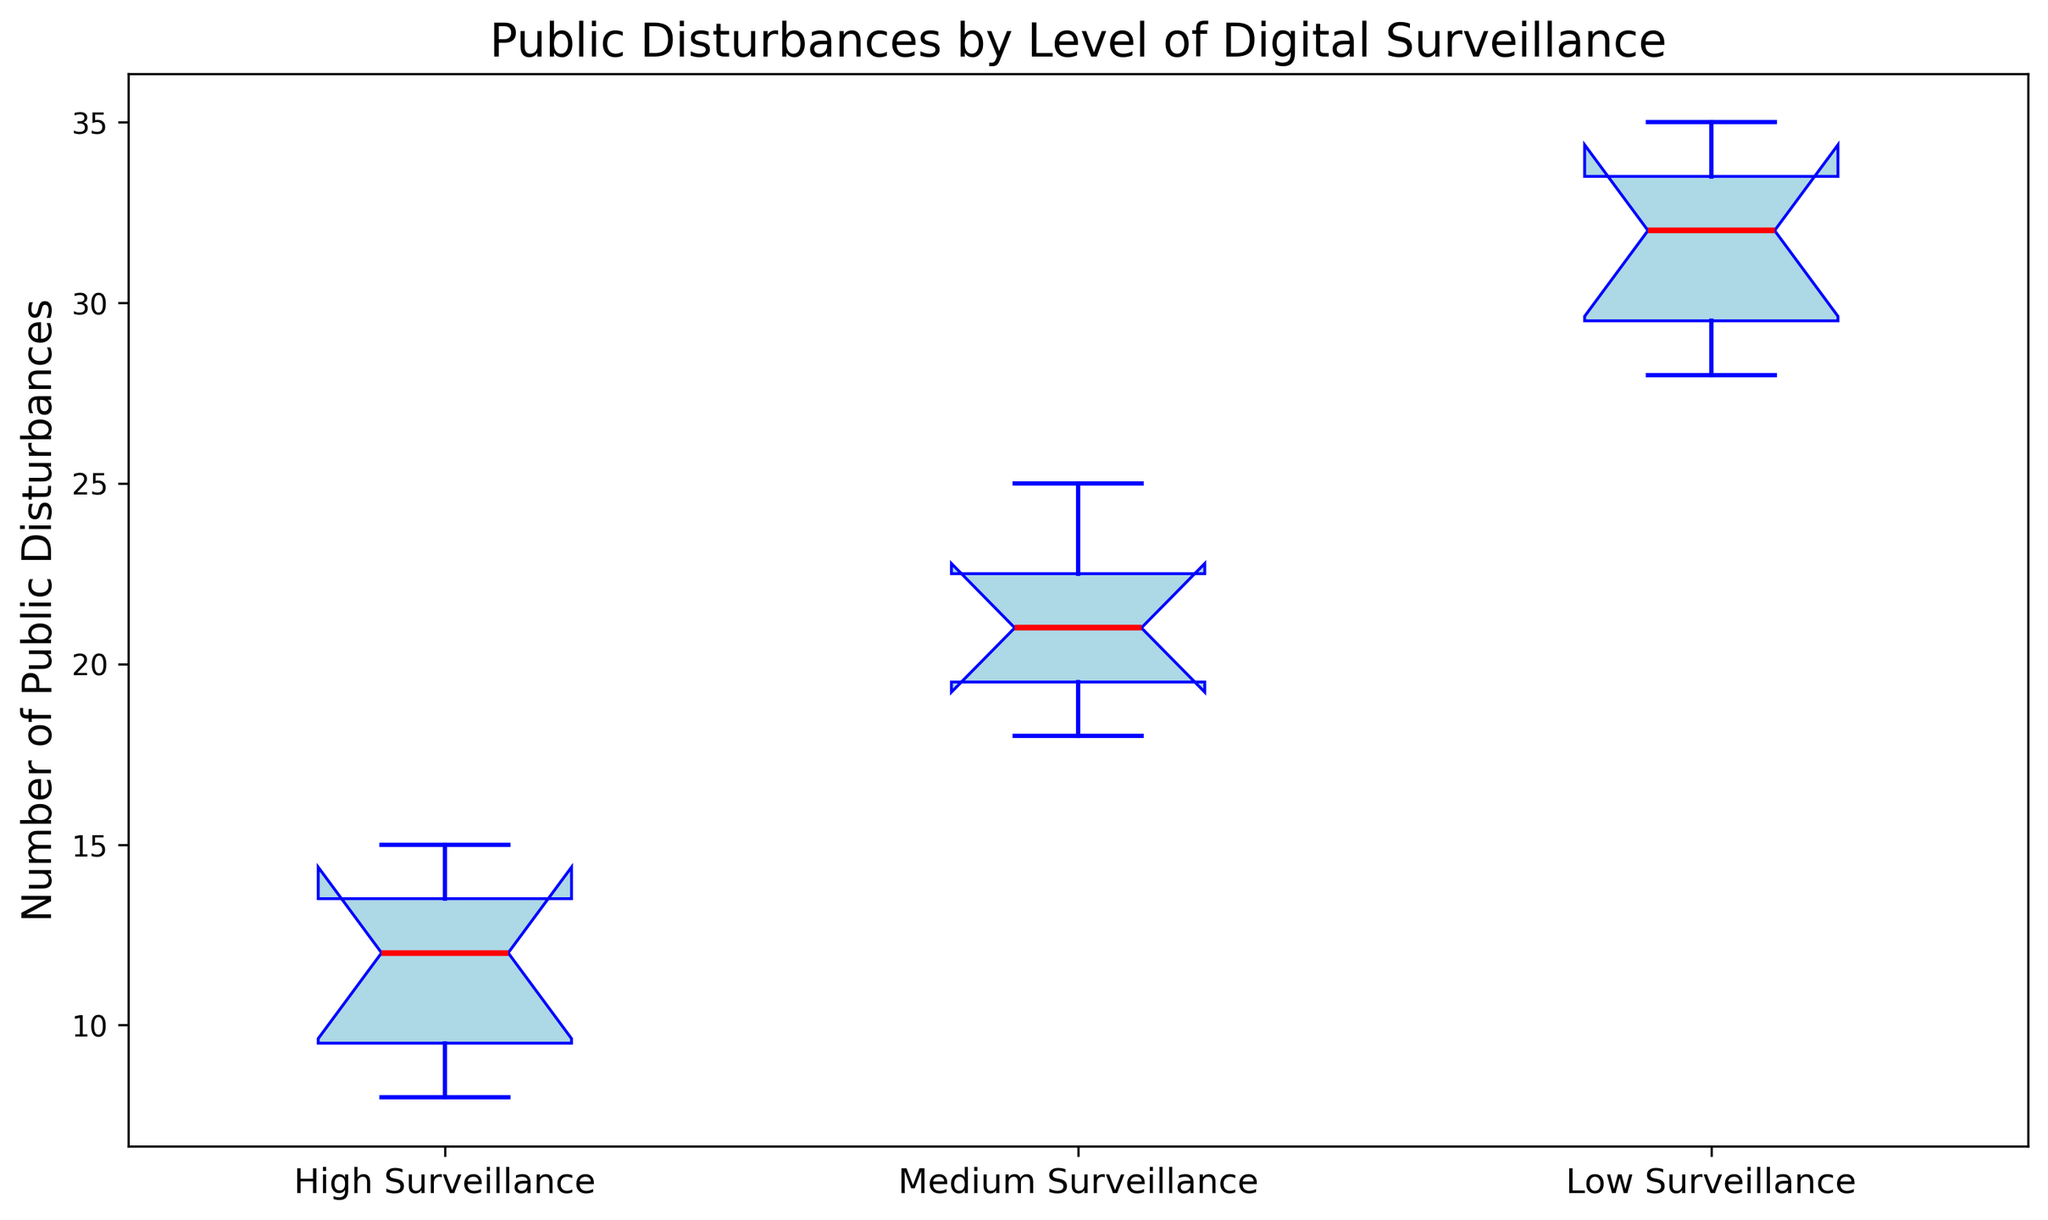What is the median number of public disturbances in the Medium Surveillance group? Look at the central red line within the Medium Surveillance box plot to find the median number of public disturbances.
Answer: 21 Which surveillance level has the smallest interquartile range (IQR)? Compare the heights of the boxes (bounded by the first quartile -Q1- at the bottom and the third quartile -Q3- at the top) for each surveillance level. The smallest box represents the smallest IQR.
Answer: High Surveillance Does High Surveillance have any outliers? Check for any points outside the whiskers (those beyond the whisker ends represent outliers) for High Surveillance.
Answer: No What is the range of public disturbances in Low Surveillance? Identify the minimum (bottom whisker) and the maximum (top whisker) public disturbances in the Low Surveillance group, then calculate the difference.
Answer: 7 Which surveillance level has the highest median public disturbances? Locate the red median lines in all three box plots and compare their positions. The highest red line represents the highest median.
Answer: Low Surveillance How does the median number of public disturbances in Medium Surveillance compare to High Surveillance? Compare the positions of the red median lines for Medium Surveillance and High Surveillance.
Answer: The median in Medium Surveillance is higher than High Surveillance What is the difference between the third quartile of Low Surveillance and the first quartile of Medium Surveillance? Identify the third quartile (top of the box) for Low Surveillance and the first quartile (bottom of the box) for Medium Surveillance, then calculate the difference.
Answer: 12 Which group has the lowest maximum value of public disturbances? Find the top end of the whisker (maximum value) for each surveillance level and identify the lowest one.
Answer: High Surveillance How does the spread (variance) of public disturbances compare between Medium and Low Surveillance levels? Look at the widths of the boxes and lengths of the whiskers. Longer boxes and whiskers indicate higher variance. Compare these features between Medium and Low Surveillance.
Answer: The spread in Low Surveillance is greater than in Medium Surveillance What is the difference in medians between High and Low Surveillance? Find and compare the median values (red lines) in the box plots for High and Low Surveillance, then subtract to find the difference.
Answer: 13 